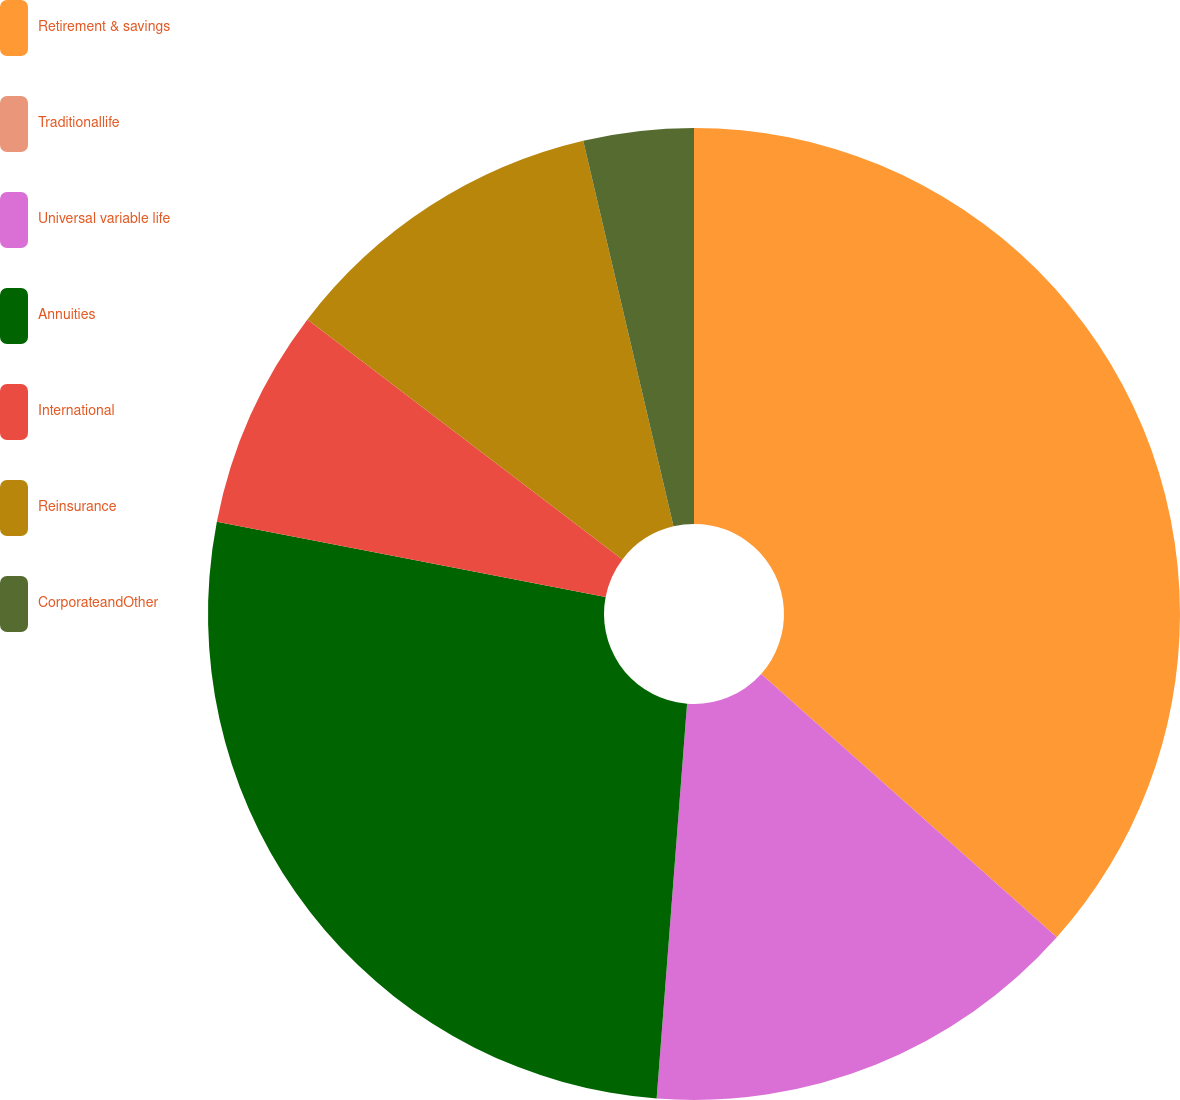Convert chart. <chart><loc_0><loc_0><loc_500><loc_500><pie_chart><fcel>Retirement & savings<fcel>Traditionallife<fcel>Universal variable life<fcel>Annuities<fcel>International<fcel>Reinsurance<fcel>CorporateandOther<nl><fcel>36.59%<fcel>0.0%<fcel>14.64%<fcel>26.82%<fcel>7.32%<fcel>10.98%<fcel>3.66%<nl></chart> 